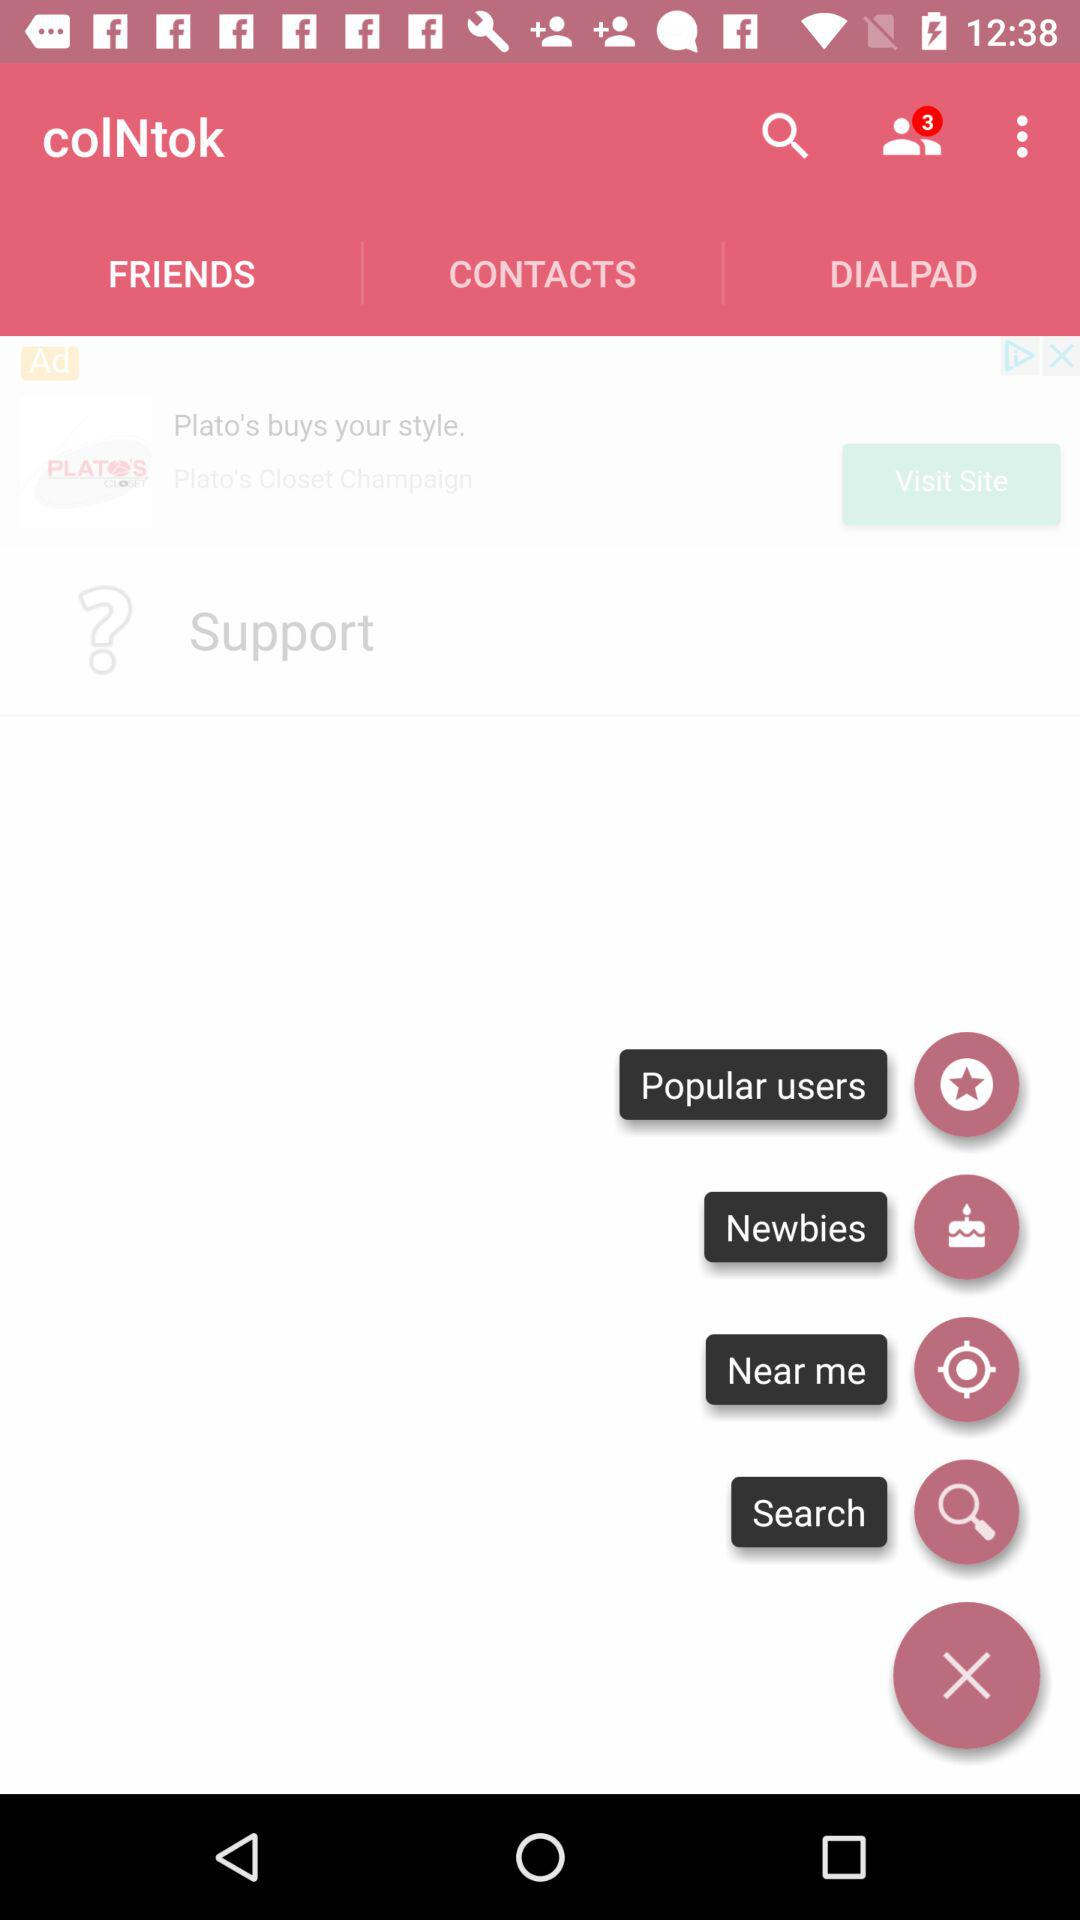What is the number of new notifications? The number of new notifications is 3. 